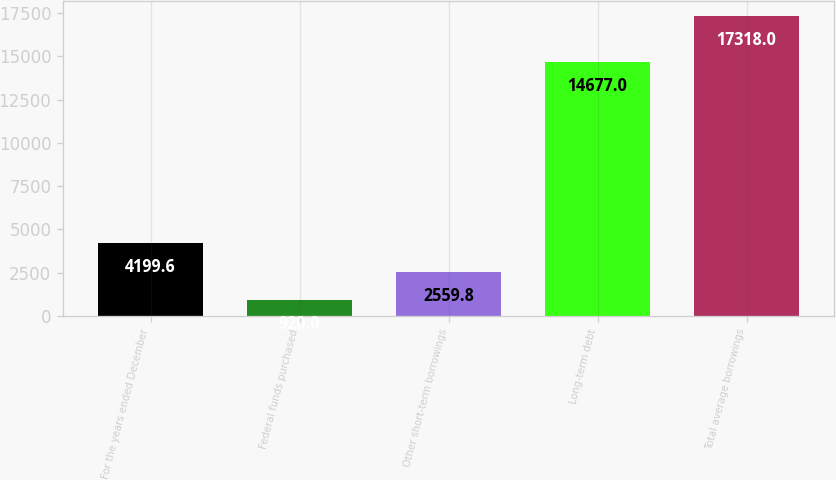<chart> <loc_0><loc_0><loc_500><loc_500><bar_chart><fcel>For the years ended December<fcel>Federal funds purchased<fcel>Other short-term borrowings<fcel>Long-term debt<fcel>Total average borrowings<nl><fcel>4199.6<fcel>920<fcel>2559.8<fcel>14677<fcel>17318<nl></chart> 